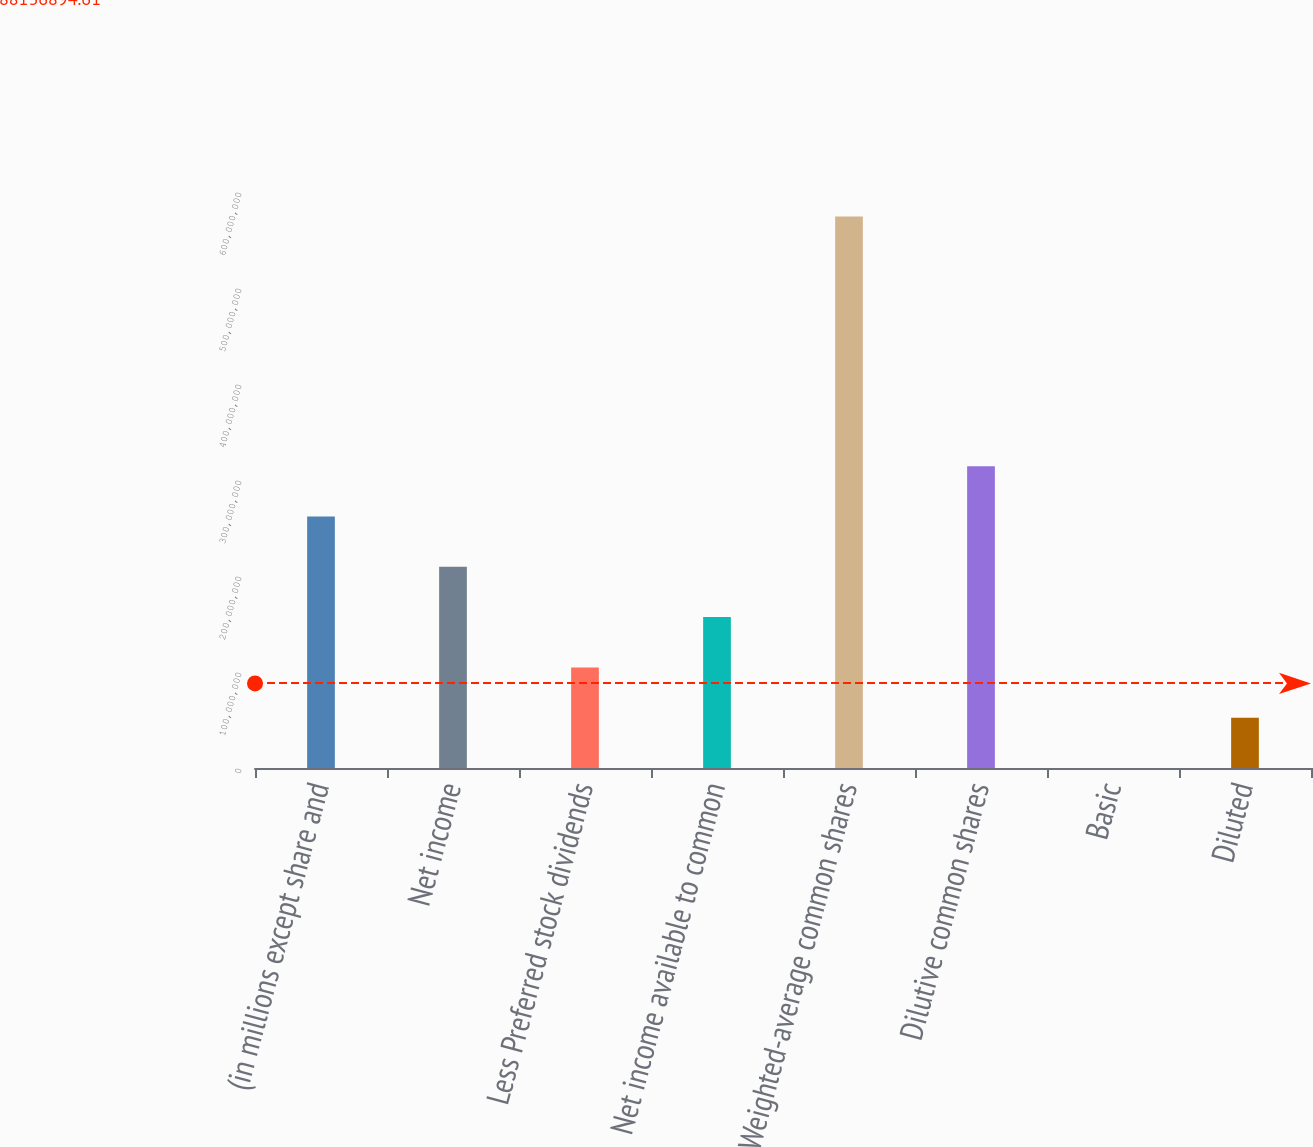Convert chart. <chart><loc_0><loc_0><loc_500><loc_500><bar_chart><fcel>(in millions except share and<fcel>Net income<fcel>Less Preferred stock dividends<fcel>Net income available to common<fcel>Weighted-average common shares<fcel>Dilutive common shares<fcel>Basic<fcel>Diluted<nl><fcel>2.61965e+08<fcel>2.09572e+08<fcel>1.04786e+08<fcel>1.57179e+08<fcel>5.74487e+08<fcel>3.14358e+08<fcel>1.97<fcel>5.23931e+07<nl></chart> 